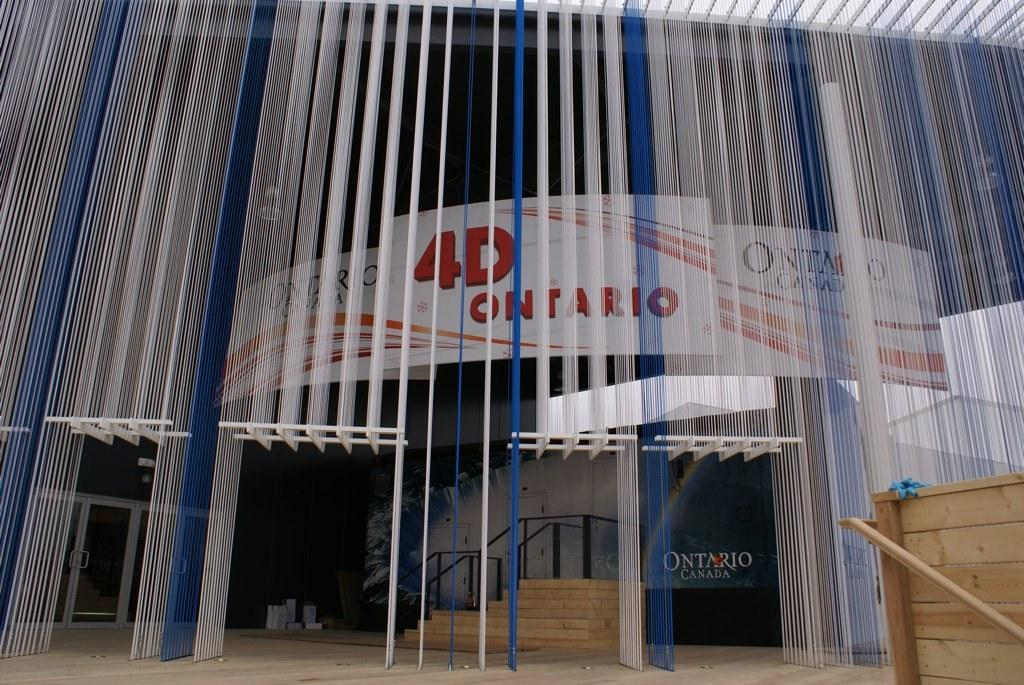What type of structure is visible in the image? There is a building in the image. What can be seen on the building in the image? There are advertisements and name boards visible on the building in the image. How can people access different floors of the building? There is a staircase in the image, which suggests that people can use it to access different floors. What safety feature is present in the image? Railings are visible in the image, which indicates that they are likely used for safety purposes. Can you tell me how deep the lake is in the image? There is no lake present in the image; it features a building with advertisements, name boards, a staircase, and railings. 